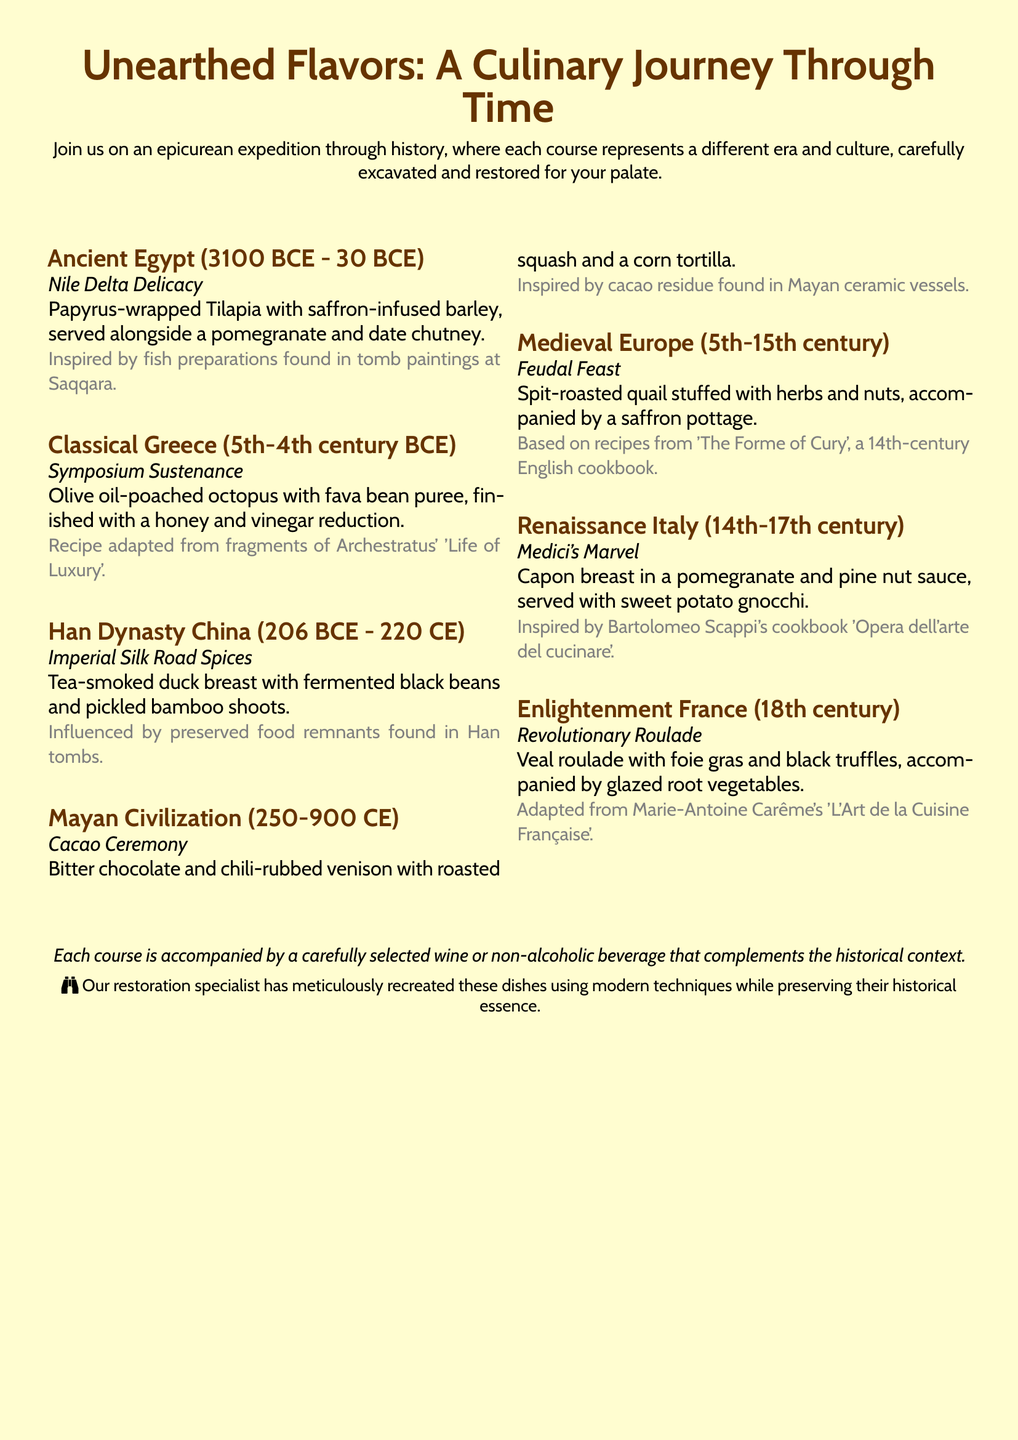What is the title of the event? The title of the event is prominently displayed at the top of the document.
Answer: Unearthed Flavors: A Culinary Journey Through Time What is served in the Ancient Egypt course? The dish served in the Ancient Egypt course is listed under the corresponding section.
Answer: Papyrus-wrapped Tilapia with saffron-infused barley Which civilization does the Cacao Ceremony represent? The Civilization represented by the Cacao Ceremony is mentioned in the respective course heading.
Answer: Mayan Civilization What is one ingredient in the Medici's Marvel dish? Ingredients of the Medici's Marvel dish are provided in the description.
Answer: Pomegranate From which cookbook is the Feudal Feast recipe inspired? The inspiration for the Feudal Feast dish is given in the course description.
Answer: The Forme of Cury What historical period does the Revolutionary Roulade belong to? Each course is associated with a specific historical period, mentioned in the heading.
Answer: Enlightenment France How many courses are included in the menu? The total number of courses can be counted from the course listings in the document.
Answer: Seven What type of beverage accompanies each course? The additional detail about beverages is provided towards the end of the document.
Answer: Wine or non-alcoholic beverage 